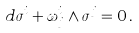<formula> <loc_0><loc_0><loc_500><loc_500>d \sigma ^ { i } + \omega ^ { i } _ { j } \wedge \sigma ^ { j } = 0 \, .</formula> 